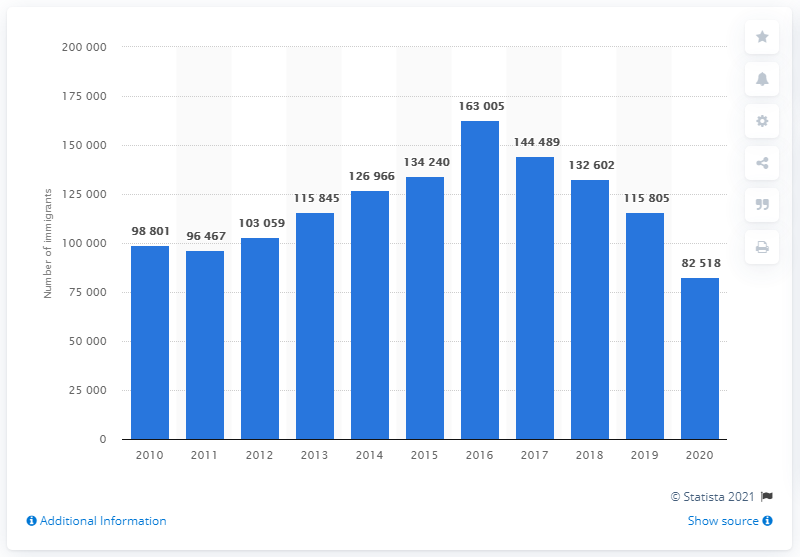Highlight a few significant elements in this photo. In 2016, Sweden had one of the most generous asylum laws in the European Union. In 2020, 82,518 individuals arrived in Sweden. In 2016, 163,005 people immigrated to Sweden. 